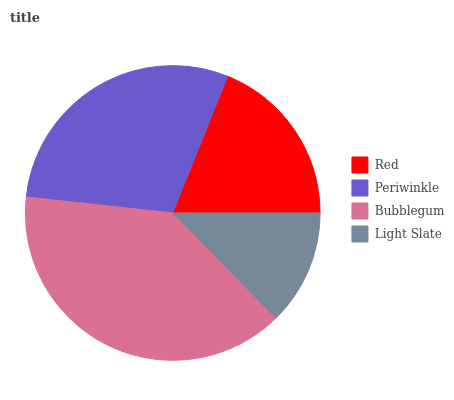Is Light Slate the minimum?
Answer yes or no. Yes. Is Bubblegum the maximum?
Answer yes or no. Yes. Is Periwinkle the minimum?
Answer yes or no. No. Is Periwinkle the maximum?
Answer yes or no. No. Is Periwinkle greater than Red?
Answer yes or no. Yes. Is Red less than Periwinkle?
Answer yes or no. Yes. Is Red greater than Periwinkle?
Answer yes or no. No. Is Periwinkle less than Red?
Answer yes or no. No. Is Periwinkle the high median?
Answer yes or no. Yes. Is Red the low median?
Answer yes or no. Yes. Is Red the high median?
Answer yes or no. No. Is Light Slate the low median?
Answer yes or no. No. 